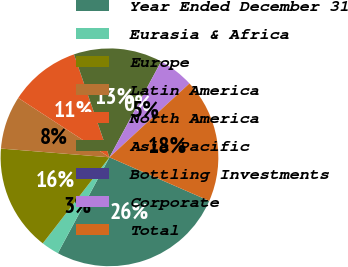Convert chart. <chart><loc_0><loc_0><loc_500><loc_500><pie_chart><fcel>Year Ended December 31<fcel>Eurasia & Africa<fcel>Europe<fcel>Latin America<fcel>North America<fcel>Asia Pacific<fcel>Bottling Investments<fcel>Corporate<fcel>Total<nl><fcel>26.31%<fcel>2.63%<fcel>15.79%<fcel>7.9%<fcel>10.53%<fcel>13.16%<fcel>0.0%<fcel>5.26%<fcel>18.42%<nl></chart> 